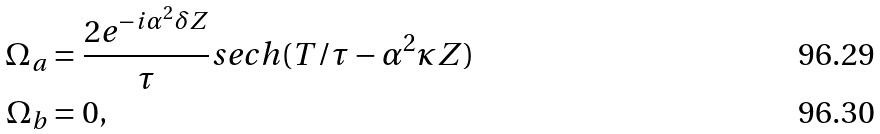Convert formula to latex. <formula><loc_0><loc_0><loc_500><loc_500>\Omega _ { a } & = \frac { 2 e ^ { - i \alpha ^ { 2 } \delta Z } } { \tau } s e c h ( T / \tau - \alpha ^ { 2 } \kappa Z ) \\ \Omega _ { b } & = 0 ,</formula> 